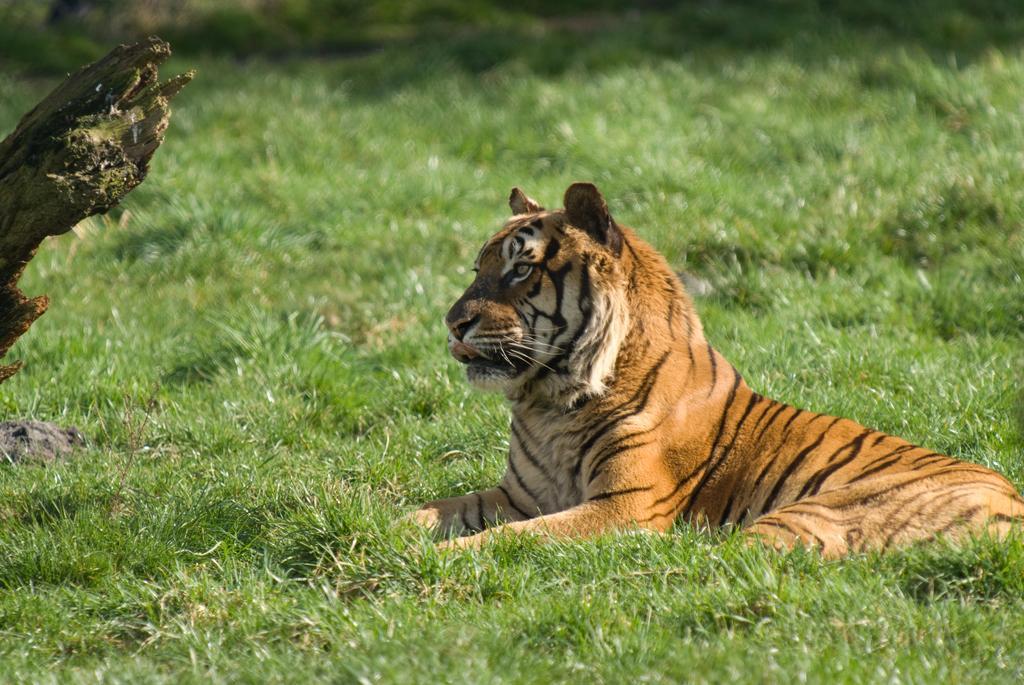Can you describe this image briefly? In this picture we can see a tiger sitting on the grass and looking somewhere. 